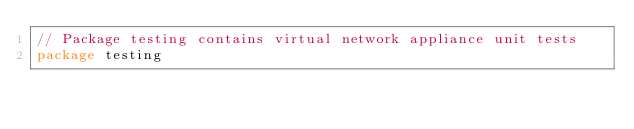Convert code to text. <code><loc_0><loc_0><loc_500><loc_500><_Go_>// Package testing contains virtual network appliance unit tests
package testing
</code> 